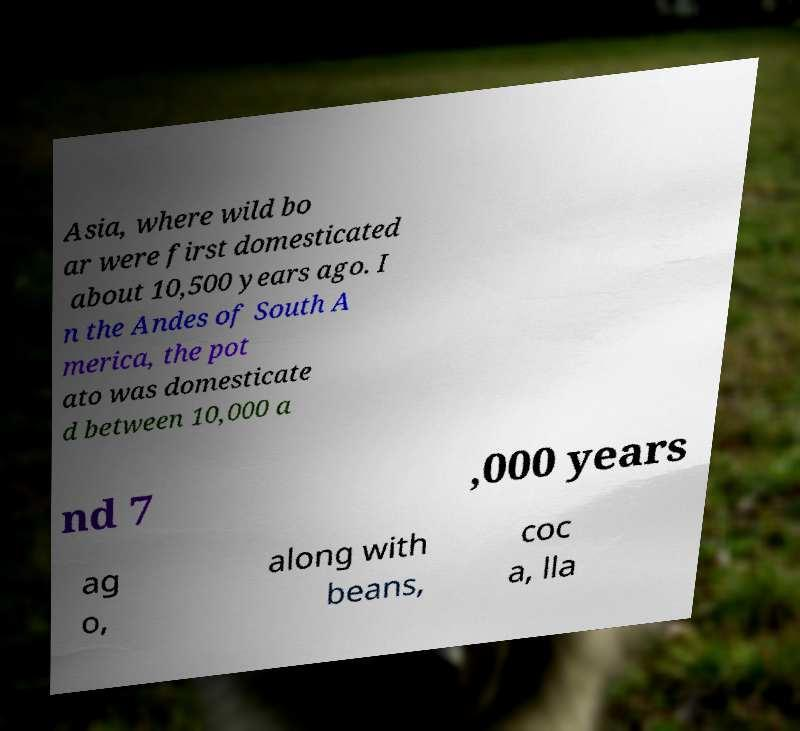For documentation purposes, I need the text within this image transcribed. Could you provide that? Asia, where wild bo ar were first domesticated about 10,500 years ago. I n the Andes of South A merica, the pot ato was domesticate d between 10,000 a nd 7 ,000 years ag o, along with beans, coc a, lla 